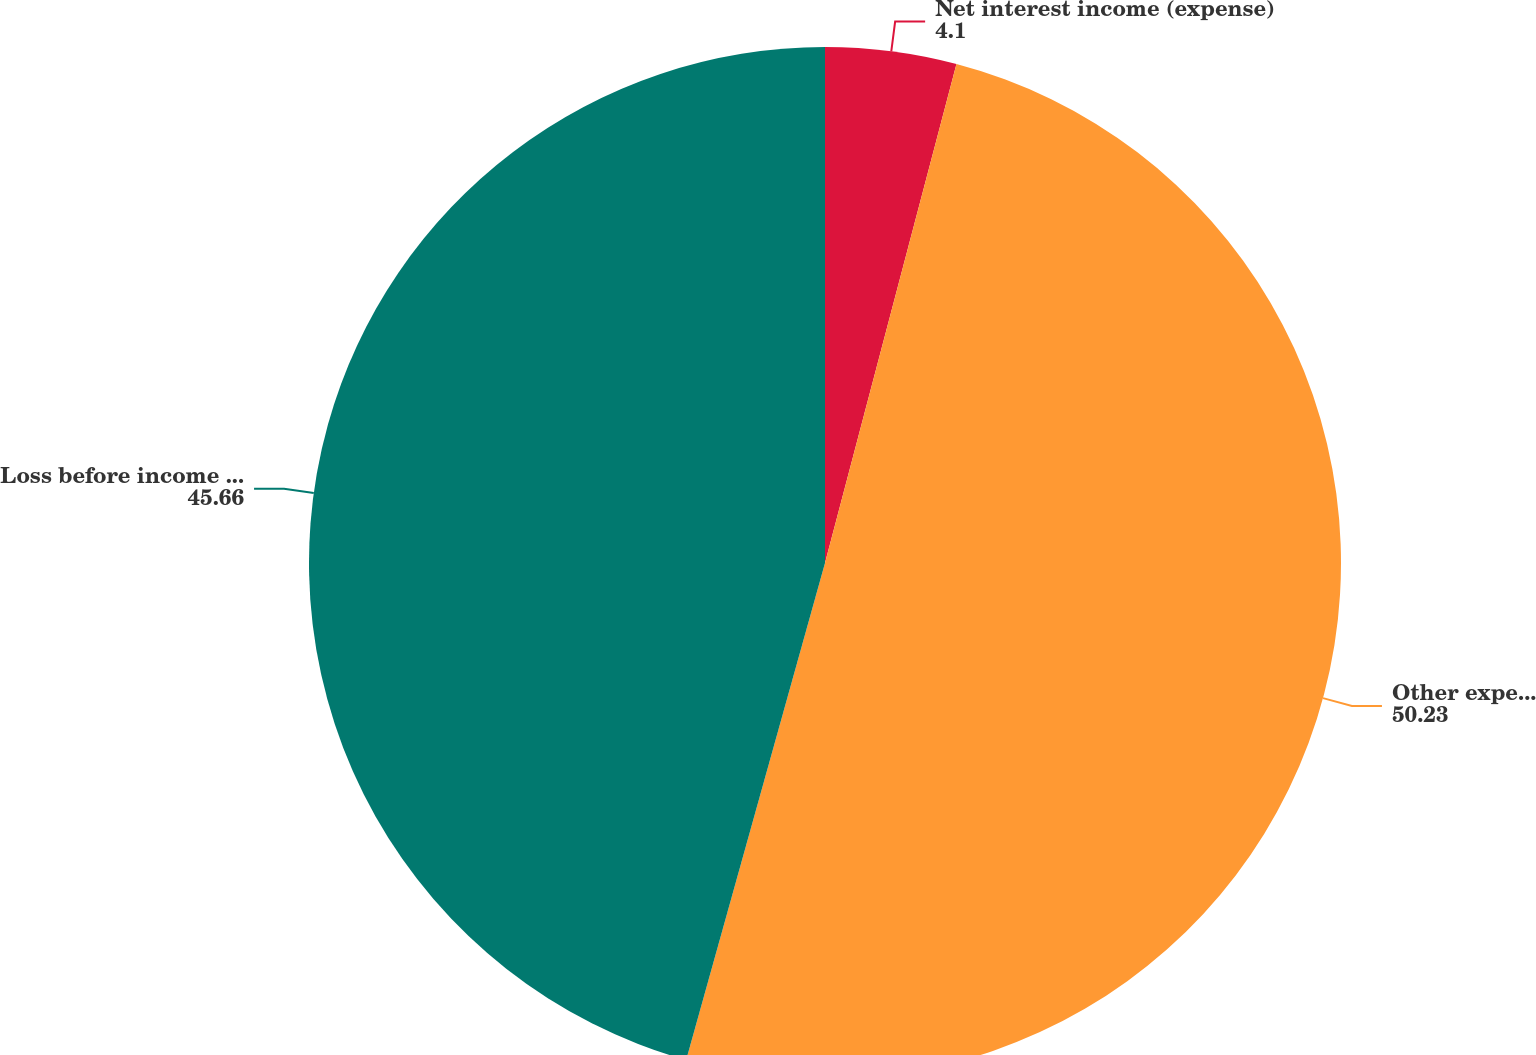Convert chart to OTSL. <chart><loc_0><loc_0><loc_500><loc_500><pie_chart><fcel>Net interest income (expense)<fcel>Other expenses net<fcel>Loss before income taxes<nl><fcel>4.1%<fcel>50.23%<fcel>45.66%<nl></chart> 